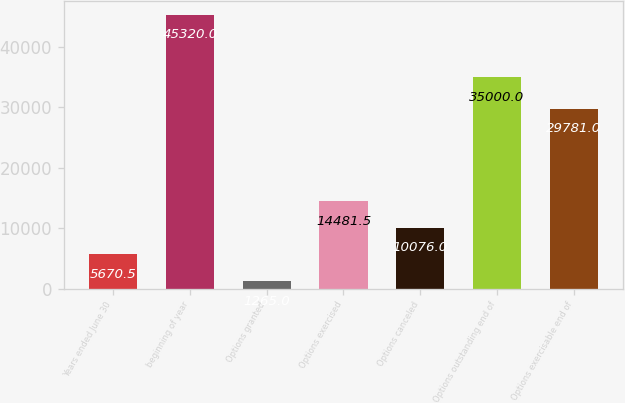Convert chart to OTSL. <chart><loc_0><loc_0><loc_500><loc_500><bar_chart><fcel>Years ended June 30<fcel>beginning of year<fcel>Options granted<fcel>Options exercised<fcel>Options canceled<fcel>Options outstanding end of<fcel>Options exercisable end of<nl><fcel>5670.5<fcel>45320<fcel>1265<fcel>14481.5<fcel>10076<fcel>35000<fcel>29781<nl></chart> 